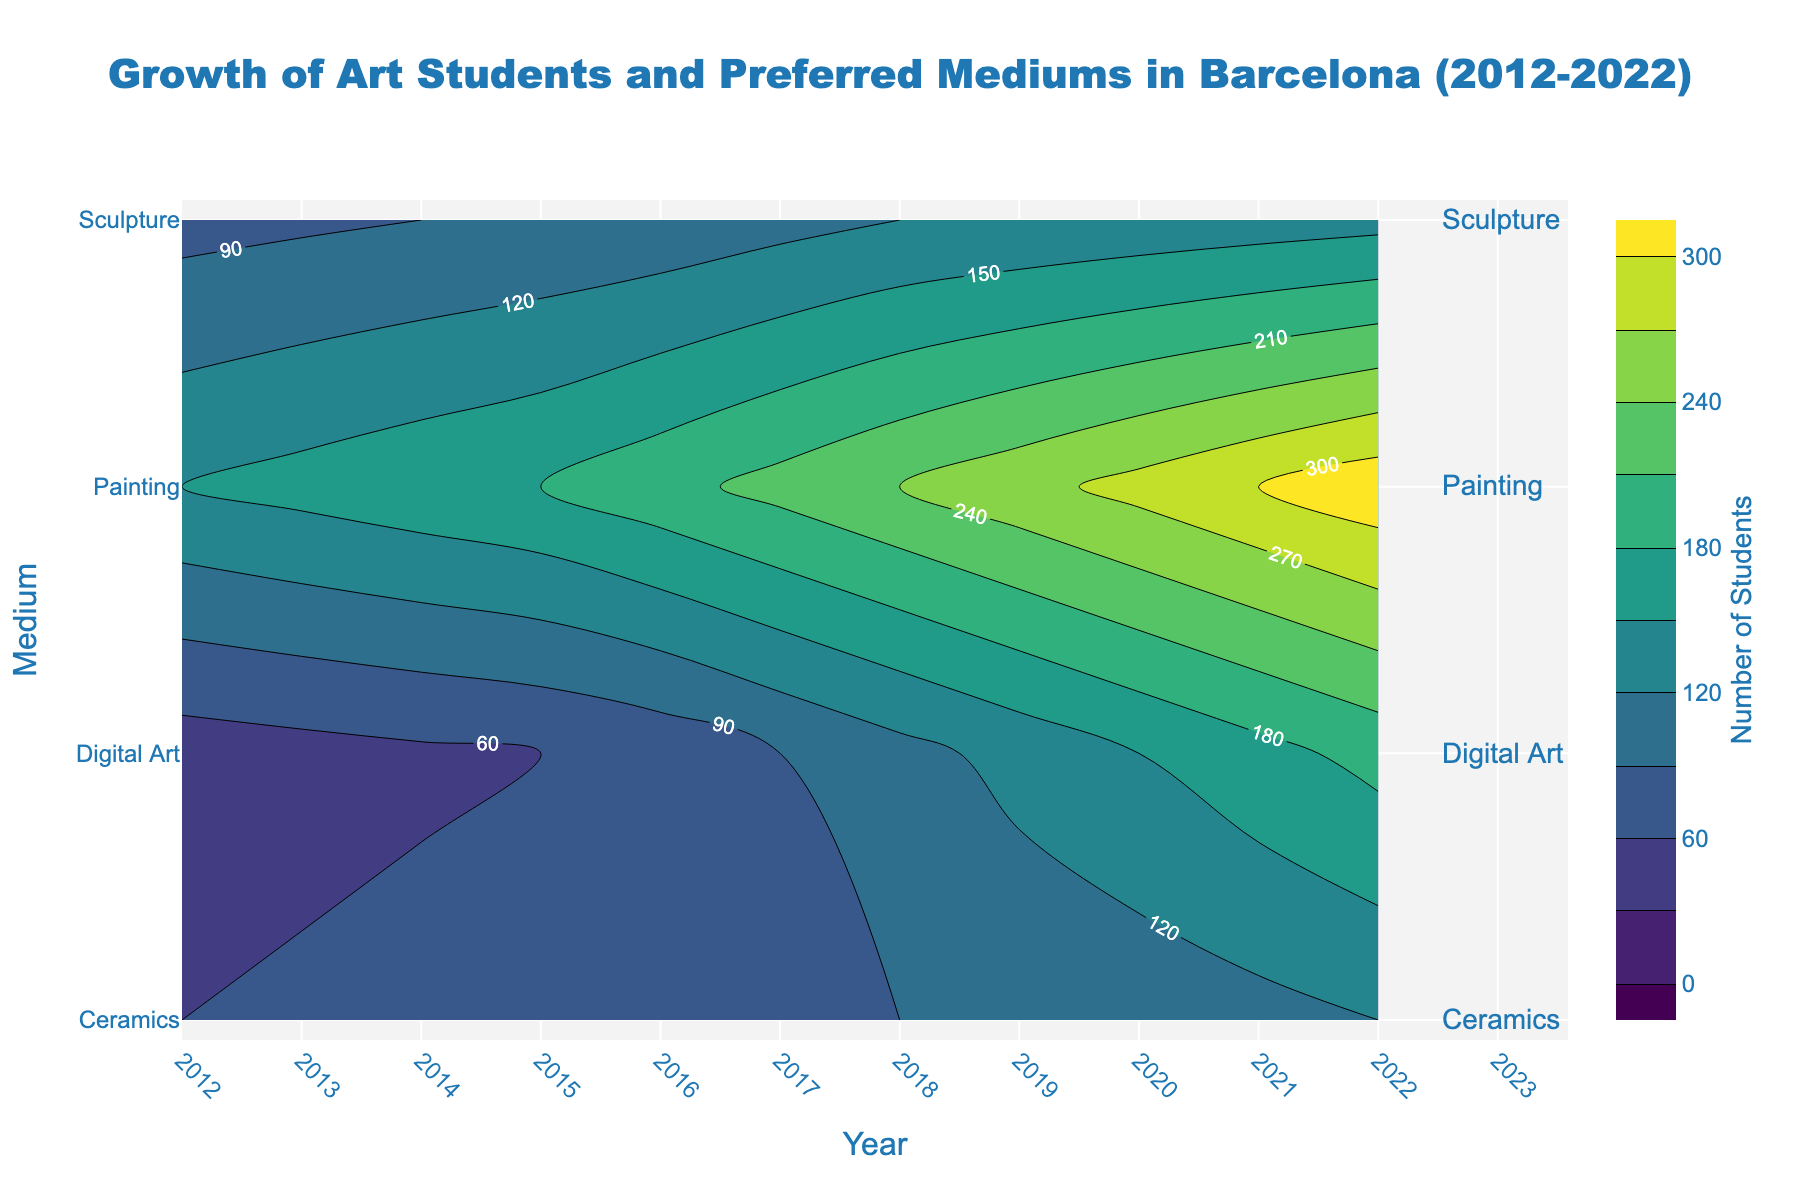How many preferred mediums are displayed in the contour plot? Count the number of unique medium names on the y-axis.
Answer: 4 What is the general trend in the number of students studying Painting? Observe the contour lines and labels for 'Painting' over the years. The number of students increases from 150 in 2012 to 320 in 2022.
Answer: Increasing Which medium saw the highest number of students in any given year? Look for the contour labels with the highest number close to 'Painting' in 2022 with 320 students.
Answer: Painting Did the number of students preferring Ceramics ever exceed 100? Check for the contour labels in the 'Ceramics' row; in 2021, the number reaches 110.
Answer: Yes Between 2015 and 2020, which medium had the most significant increase in students? Calculate the difference from 2015 to 2020 for each medium and compare. For 'Painting', the increase is 100 (200 to 300); for 'Sculpture', it's 35 (95 to 130); for 'Digital Art', it's 90 (60 to 150); for 'Ceramics', it's 25 (75 to 100).
Answer: Painting By how much did the number of students studying Digital Art increase from 2012 to 2022? Subtract the number of students in Digital Art in 2012 (45) from the number in 2022 (190).
Answer: 145 Which year saw the biggest jump in the number of students for Sculpture? Look at the 'Sculpture' contour labels and find the year-to-year increases; the largest is from 2017 to 2018, where it increased by 10 students (110 to 120).
Answer: 2017 to 2018 For the year 2018, rank the mediums in terms of student preference from highest to lowest. Check the contour labels for 2018: Painting (240), Sculpture (120), Digital Art (110), and Ceramics (90).
Answer: Painting, Sculpture, Digital Art, Ceramics Comparing the periods of 2012-2017 and 2017-2022, which period showed greater growth in the number of students for Digital Art? Calculate growth for each period: 2012-2017: 45 to 90 (increase of 45), 2017-2022: 90 to 190 (increase of 100).
Answer: 2017-2022 What can you infer about the popularity of traditional art mediums (Painting and Sculpture) versus modern mediums (Digital Art) over the decade? Traditional mediums like Painting and Sculpture show consistent linear growth, while Digital Art shows a more rapid increase in later years. This indicates a growing interest in modern mediums over time.
Answer: Rapid growth in Digital Art, steady growth in Painting and Sculpture 